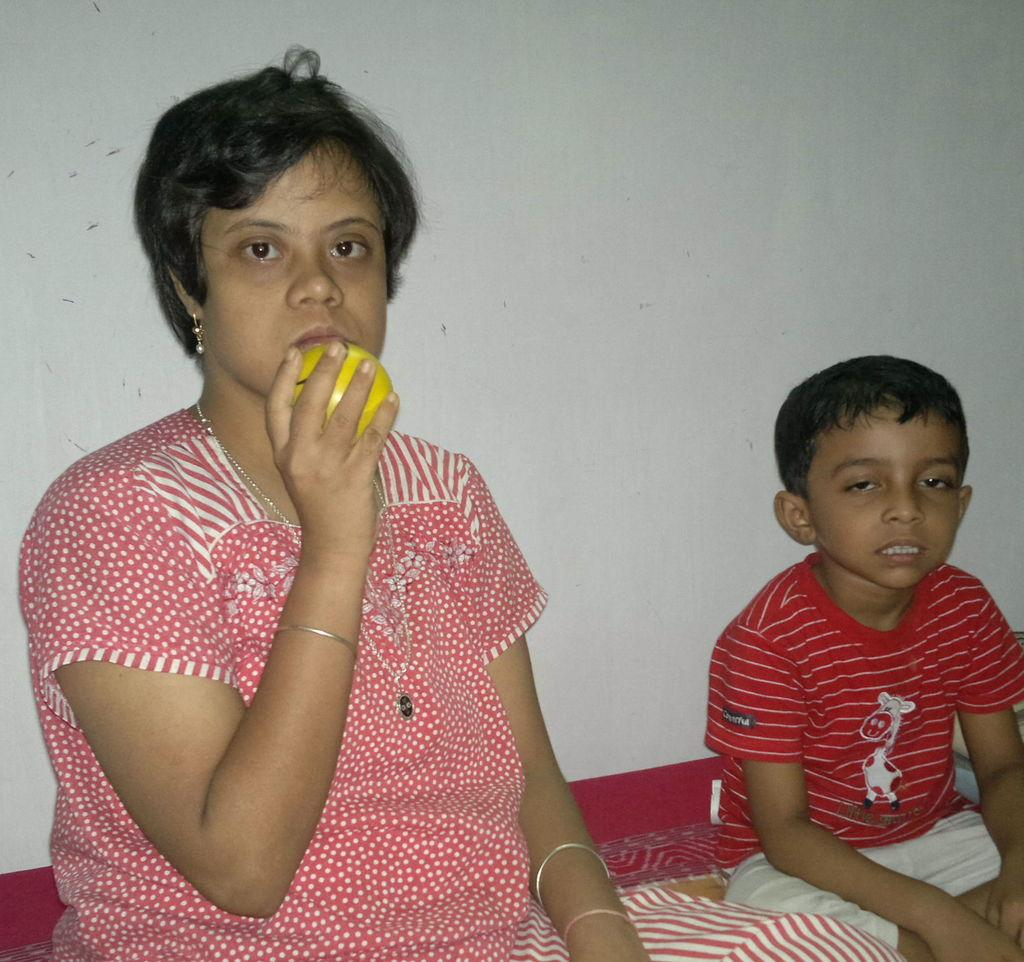Who are the people in the image? There is a woman and a boy in the image. What are the positions of the woman and the boy in the image? Both the woman and the boy are seated. What object is the woman holding in the image? The woman is holding a ball. Where is the rake being used in the image? There is no rake present in the image. What type of cave can be seen in the background of the image? There is no cave present in the image. 